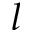<formula> <loc_0><loc_0><loc_500><loc_500>l</formula> 